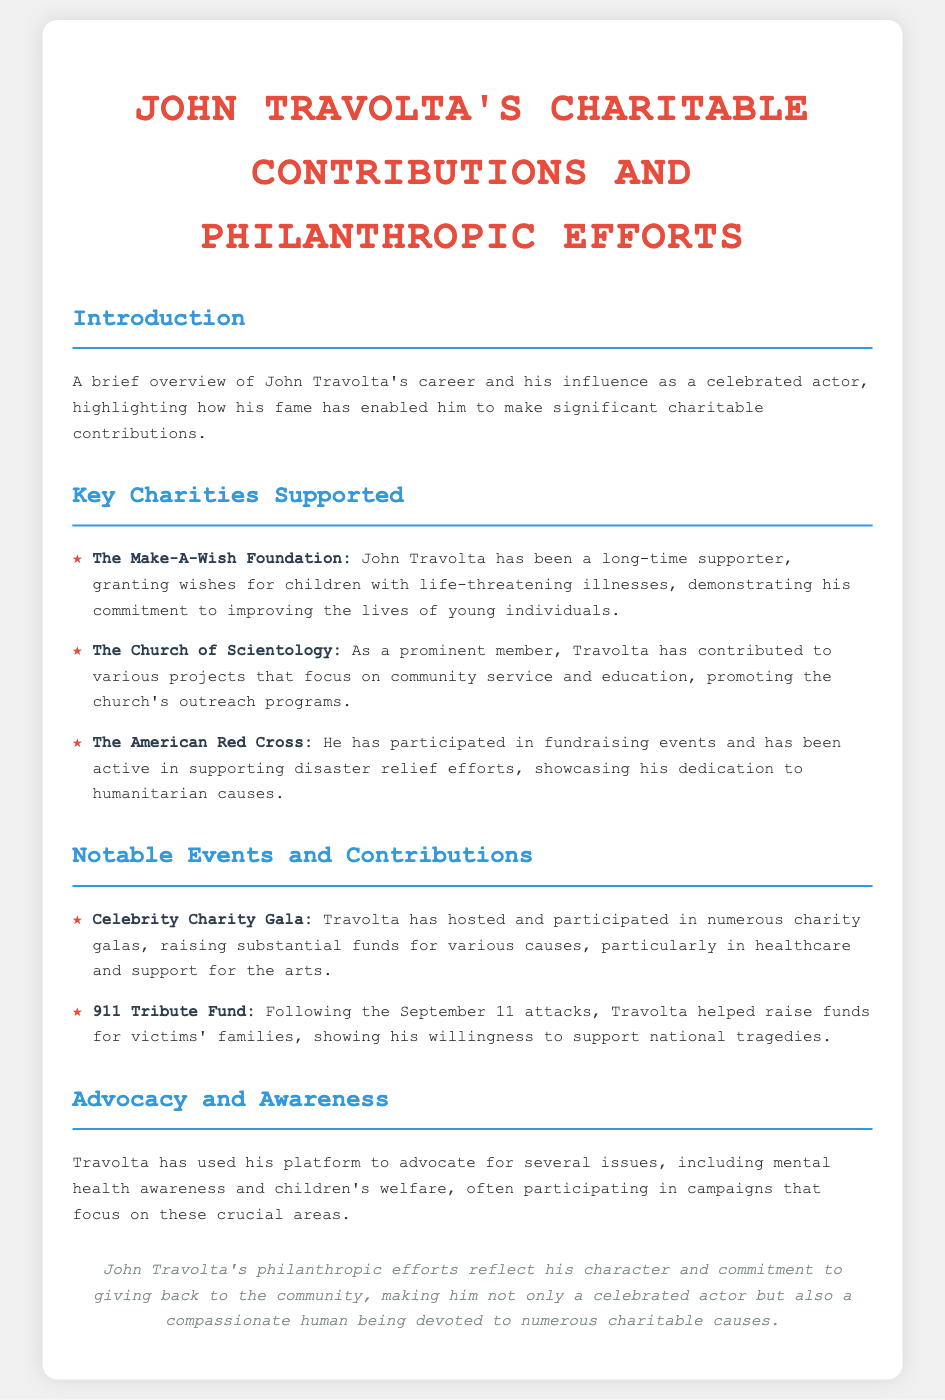What is the primary focus of John Travolta's charitable contributions? The document highlights Travolta's contributions to various charities, focusing on improving the lives of individuals, particularly children.
Answer: Improving lives Which charity has John Travolta supported the longest? The document mentions that Travolta has been a long-time supporter of the Make-A-Wish Foundation.
Answer: Make-A-Wish Foundation What event did Travolta help fundraise for after the September 11 attacks? The document states that he helped raise funds for the 911 Tribute Fund in response to the national tragedy.
Answer: 911 Tribute Fund What type of events does Travolta frequently participate in? The document lists that Travolta has hosted and participated in numerous charity galas to raise funds.
Answer: Charity galas What cause did Travolta advocate for besides children's welfare? The document implies that he advocates for mental health awareness as well.
Answer: Mental health awareness What type of humanitarian organization is the American Red Cross? The document describes it as a humanitarian organization that supports disaster relief efforts.
Answer: Humanitarian What is Travolta's relationship with the Church of Scientology? The document states he is a prominent member who contributes to various community service and education projects.
Answer: Prominent member How does Travolta use his platform in relation to charitable efforts? The document indicates he uses it to advocate for important social issues and participate in related campaigns.
Answer: Advocate for social issues 